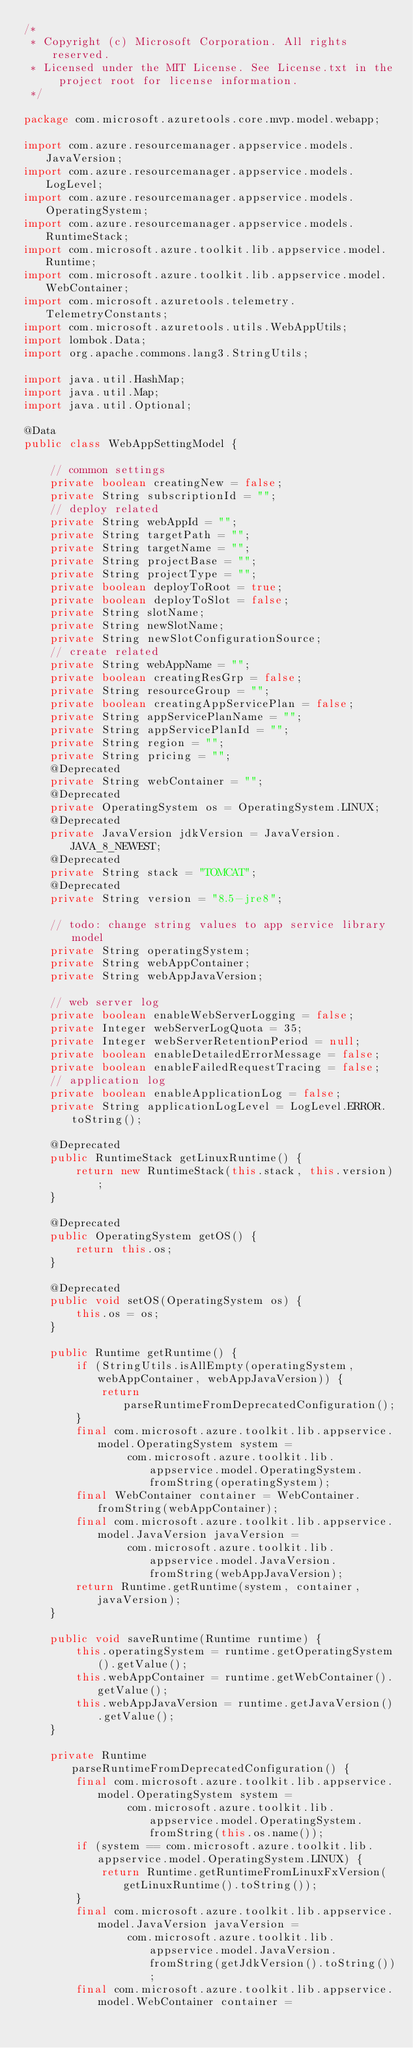<code> <loc_0><loc_0><loc_500><loc_500><_Java_>/*
 * Copyright (c) Microsoft Corporation. All rights reserved.
 * Licensed under the MIT License. See License.txt in the project root for license information.
 */

package com.microsoft.azuretools.core.mvp.model.webapp;

import com.azure.resourcemanager.appservice.models.JavaVersion;
import com.azure.resourcemanager.appservice.models.LogLevel;
import com.azure.resourcemanager.appservice.models.OperatingSystem;
import com.azure.resourcemanager.appservice.models.RuntimeStack;
import com.microsoft.azure.toolkit.lib.appservice.model.Runtime;
import com.microsoft.azure.toolkit.lib.appservice.model.WebContainer;
import com.microsoft.azuretools.telemetry.TelemetryConstants;
import com.microsoft.azuretools.utils.WebAppUtils;
import lombok.Data;
import org.apache.commons.lang3.StringUtils;

import java.util.HashMap;
import java.util.Map;
import java.util.Optional;

@Data
public class WebAppSettingModel {

    // common settings
    private boolean creatingNew = false;
    private String subscriptionId = "";
    // deploy related
    private String webAppId = "";
    private String targetPath = "";
    private String targetName = "";
    private String projectBase = "";
    private String projectType = "";
    private boolean deployToRoot = true;
    private boolean deployToSlot = false;
    private String slotName;
    private String newSlotName;
    private String newSlotConfigurationSource;
    // create related
    private String webAppName = "";
    private boolean creatingResGrp = false;
    private String resourceGroup = "";
    private boolean creatingAppServicePlan = false;
    private String appServicePlanName = "";
    private String appServicePlanId = "";
    private String region = "";
    private String pricing = "";
    @Deprecated
    private String webContainer = "";
    @Deprecated
    private OperatingSystem os = OperatingSystem.LINUX;
    @Deprecated
    private JavaVersion jdkVersion = JavaVersion.JAVA_8_NEWEST;
    @Deprecated
    private String stack = "TOMCAT";
    @Deprecated
    private String version = "8.5-jre8";

    // todo: change string values to app service library model
    private String operatingSystem;
    private String webAppContainer;
    private String webAppJavaVersion;

    // web server log
    private boolean enableWebServerLogging = false;
    private Integer webServerLogQuota = 35;
    private Integer webServerRetentionPeriod = null;
    private boolean enableDetailedErrorMessage = false;
    private boolean enableFailedRequestTracing = false;
    // application log
    private boolean enableApplicationLog = false;
    private String applicationLogLevel = LogLevel.ERROR.toString();

    @Deprecated
    public RuntimeStack getLinuxRuntime() {
        return new RuntimeStack(this.stack, this.version);
    }

    @Deprecated
    public OperatingSystem getOS() {
        return this.os;
    }

    @Deprecated
    public void setOS(OperatingSystem os) {
        this.os = os;
    }

    public Runtime getRuntime() {
        if (StringUtils.isAllEmpty(operatingSystem, webAppContainer, webAppJavaVersion)) {
            return parseRuntimeFromDeprecatedConfiguration();
        }
        final com.microsoft.azure.toolkit.lib.appservice.model.OperatingSystem system =
                com.microsoft.azure.toolkit.lib.appservice.model.OperatingSystem.fromString(operatingSystem);
        final WebContainer container = WebContainer.fromString(webAppContainer);
        final com.microsoft.azure.toolkit.lib.appservice.model.JavaVersion javaVersion =
                com.microsoft.azure.toolkit.lib.appservice.model.JavaVersion.fromString(webAppJavaVersion);
        return Runtime.getRuntime(system, container, javaVersion);
    }

    public void saveRuntime(Runtime runtime) {
        this.operatingSystem = runtime.getOperatingSystem().getValue();
        this.webAppContainer = runtime.getWebContainer().getValue();
        this.webAppJavaVersion = runtime.getJavaVersion().getValue();
    }

    private Runtime parseRuntimeFromDeprecatedConfiguration() {
        final com.microsoft.azure.toolkit.lib.appservice.model.OperatingSystem system =
                com.microsoft.azure.toolkit.lib.appservice.model.OperatingSystem.fromString(this.os.name());
        if (system == com.microsoft.azure.toolkit.lib.appservice.model.OperatingSystem.LINUX) {
            return Runtime.getRuntimeFromLinuxFxVersion(getLinuxRuntime().toString());
        }
        final com.microsoft.azure.toolkit.lib.appservice.model.JavaVersion javaVersion =
                com.microsoft.azure.toolkit.lib.appservice.model.JavaVersion.fromString(getJdkVersion().toString());
        final com.microsoft.azure.toolkit.lib.appservice.model.WebContainer container =</code> 